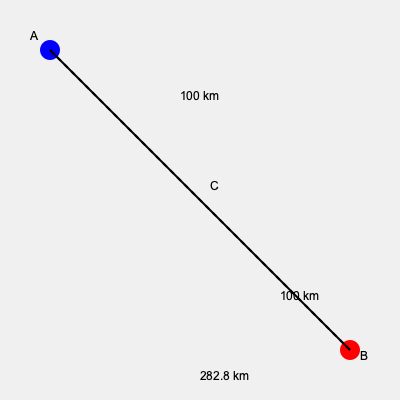A group of polar bears needs to migrate from point A to point B due to habitat loss caused by climate change. They can either travel directly from A to B or pass through point C, where there's a protected area with abundant food resources. The distances are shown in the diagram. If the bears can travel 20 km per day when moving directly and 25 km per day when passing through the protected area (due to better conditions), which route should they take to minimize their exposure to potential dangers, and how many days will the journey take? To solve this problem, we need to compare the time taken for both routes:

1. Direct route (A to B):
   Distance = 282.8 km
   Speed = 20 km/day
   Time = Distance / Speed = 282.8 / 20 = 14.14 days

2. Route through C (A to C to B):
   Total distance = 100 km + 100 km = 200 km
   Speed = 25 km/day
   Time = Distance / Speed = 200 / 25 = 8 days

Step-by-step calculation:
1. Calculate the direct distance using the Pythagorean theorem:
   $AB = \sqrt{200^2 + 200^2} = \sqrt{80,000} \approx 282.8$ km

2. Calculate time for direct route:
   $T_{direct} = 282.8 / 20 = 14.14$ days

3. Calculate time for route through C:
   $T_{through C} = (100 + 100) / 25 = 8$ days

4. Compare the two times:
   8 days < 14.14 days

The route through point C is faster and provides access to a protected area with abundant food resources. This route minimizes the bears' exposure to potential dangers by reducing travel time and providing a safe haven midway.
Answer: Route through C, 8 days 